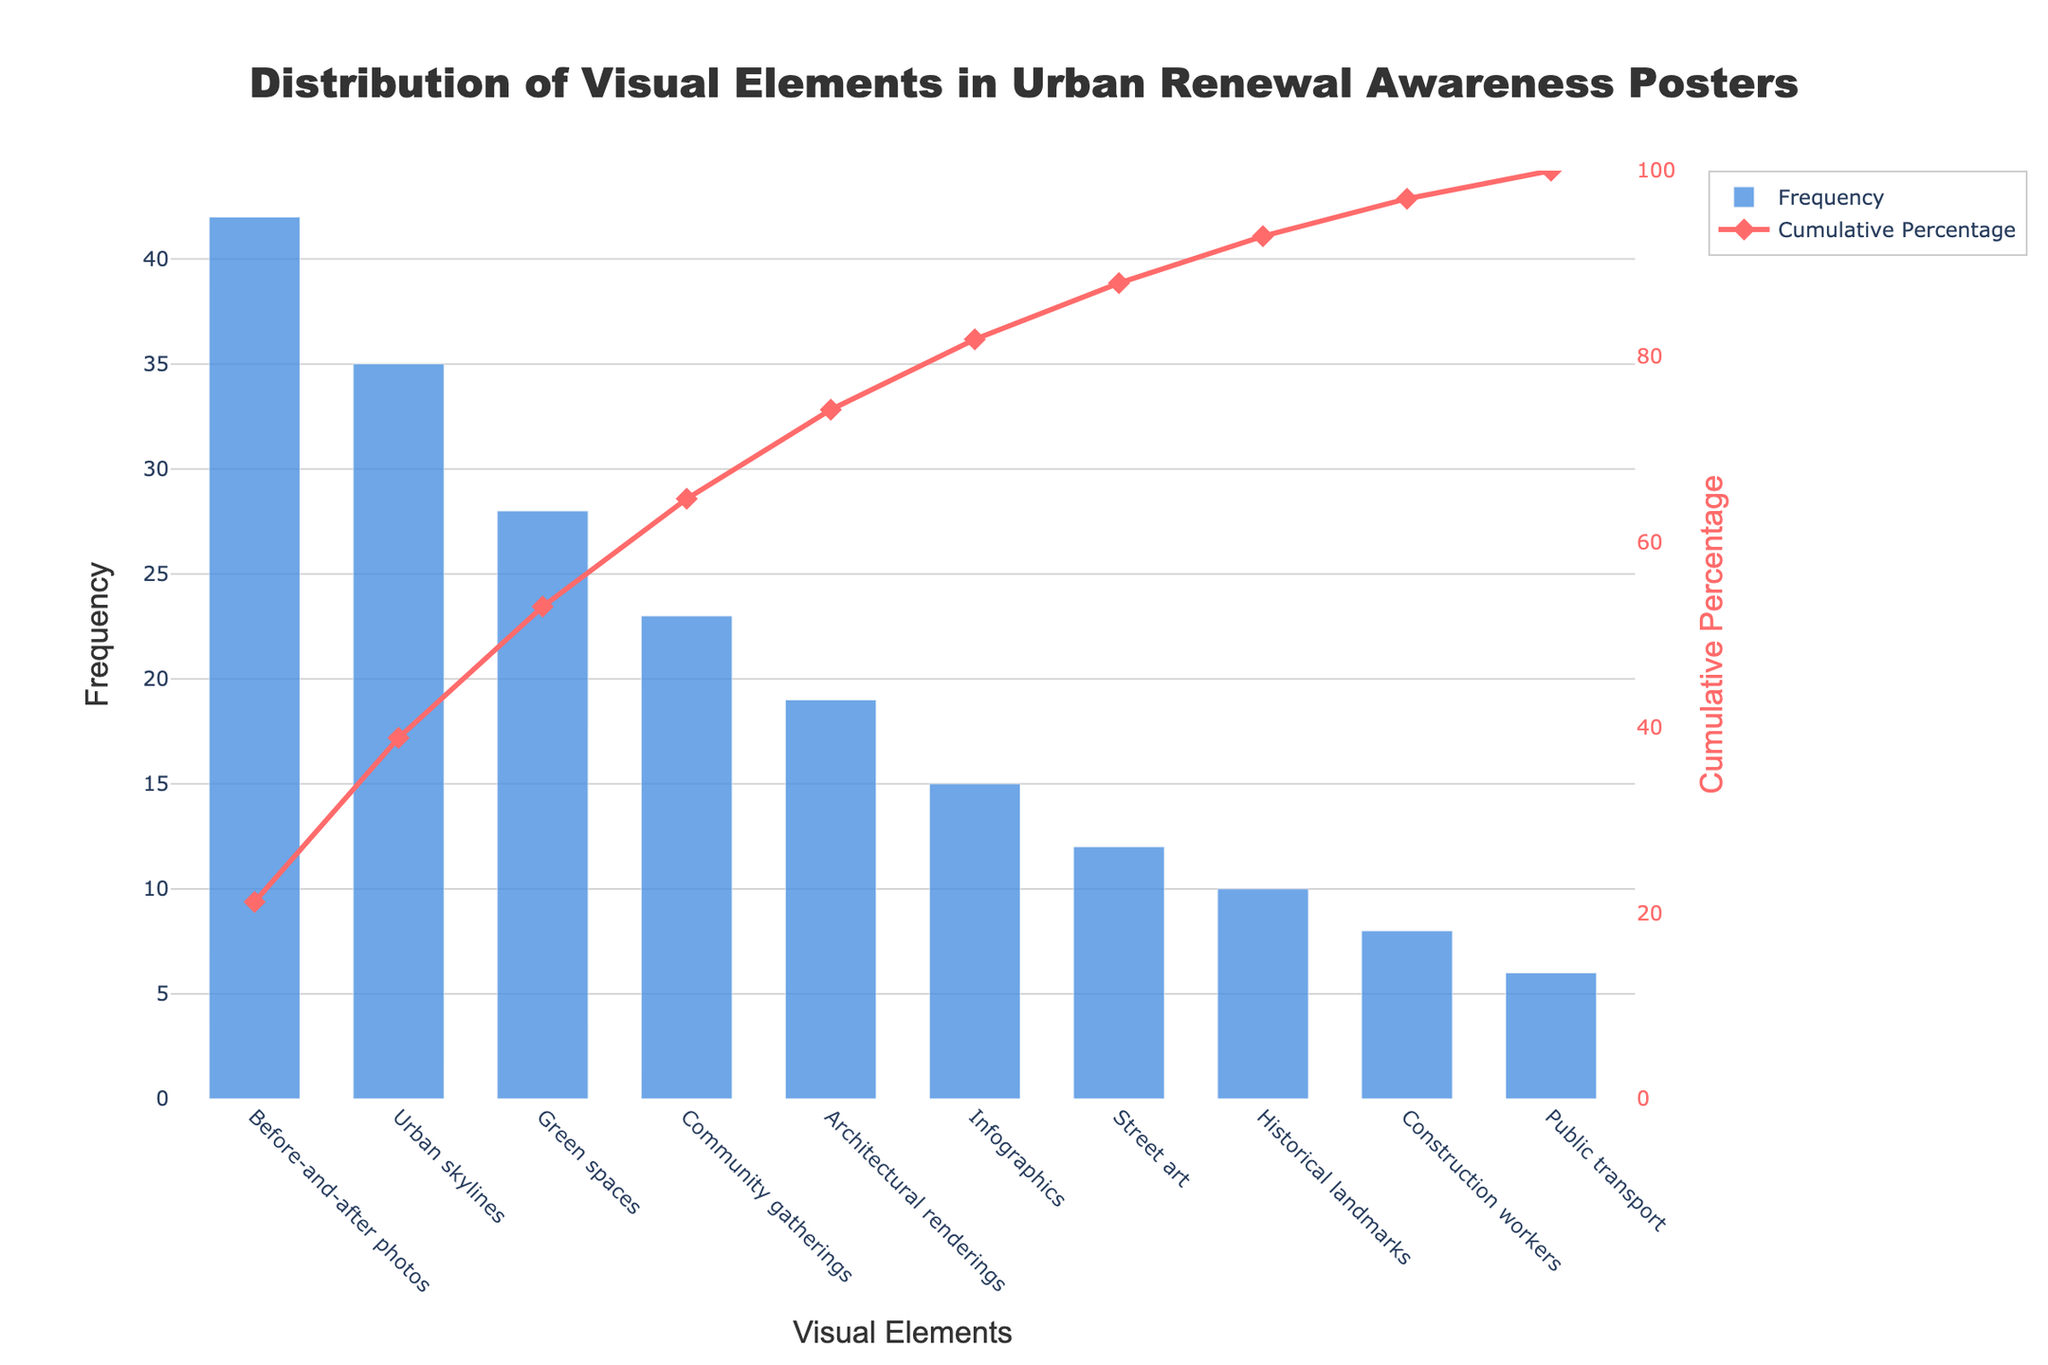What is the title of the Pareto chart? The title of the Pareto chart is typically located at the top of the figure and describes what the chart is about. In this case, the title reads "Distribution of Visual Elements in Urban Renewal Awareness Posters."
Answer: Distribution of Visual Elements in Urban Renewal Awareness Posters Which visual element has the highest frequency? The visual element with the highest frequency can be identified as the tallest bar in the bar chart. Here, it is clearly "Before-and-after photos" with a frequency of 42.
Answer: Before-and-after photos What is the cumulative percentage for the top three most frequent elements? To find the cumulative percentage for the top three most frequent elements, sum up their individual frequencies and divide by the total frequency, then multiply by 100. The top three are Before-and-after photos (42), Urban skylines (35), and Green spaces (28). Their cumulative sum is 42 + 35 + 28 = 105. The total frequency sum is 198. The cumulative percentage is (105 / 198) * 100 ≈ 53%.
Answer: 53% How does the frequency of "Green spaces" compare to "Architectural renderings"? To compare the frequencies of these two elements, look at the respective bar heights. "Green spaces" has a frequency of 28, while "Architectural renderings" has a frequency of 19. 28 is greater than 19.
Answer: Green spaces is higher Which elements contribute to achieving at least a 50% cumulative percentage? To determine which elements contribute, look at the cumulative percentage line of the Pareto chart and sum the frequencies until reaching at least 50%. Before-and-after photos (42), Urban skylines (35), and Green spaces (28) together have a cumulative percentage of around 53%, which exceeds 50%.
Answer: Before-and-after photos, Urban skylines, Green spaces What is the cumulative frequency for "Street art"? The cumulative frequency is achieved by summing up all frequencies up to "Street art." Before-and-after photos (42), Urban skylines (35), Green spaces (28), Community gatherings (23), Architectural renderings (19), Infographics (15), and then Street art (12). The cumulative frequency is 42 + 35 + 28 + 23 + 19 + 15 + 12 = 174.
Answer: 174 What proportion of the total frequency do "Community gatherings" and "Architectural renderings" make up together? First, sum the frequencies of the two elements: Community gatherings (23) and Architectural renderings (19). Their total is 23 + 19 = 42. The total frequency sum is 198, so their proportion is 42 / 198 ≈ 21.2%.
Answer: 21.2% Which visual element falls closest to a 10% contribution to the total frequency? Calculate 10% of the total frequency sum (198), which is 0.1 * 198 = 19.8. The closest frequency to 19.8 is 19, which corresponds to "Architectural renderings."
Answer: Architectural renderings How many elements have a cumulative percentage greater than 80%? To discover this, look at the Pareto chart's cumulative percentage line and count how many elements are required to exceed 80%. Upon counting, the elements up to "Public transport" need to be summed to surpass 80%. There are 9 elements in total.
Answer: 9 